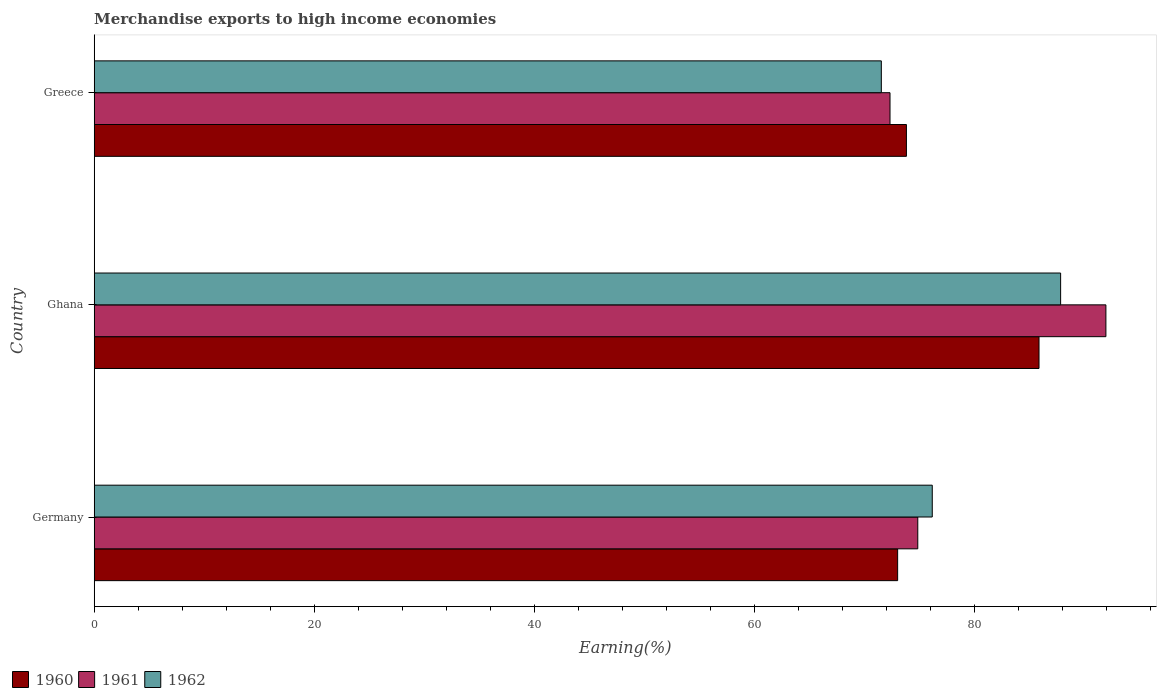How many different coloured bars are there?
Ensure brevity in your answer.  3. How many groups of bars are there?
Your answer should be compact. 3. Are the number of bars per tick equal to the number of legend labels?
Offer a terse response. Yes. Are the number of bars on each tick of the Y-axis equal?
Provide a succinct answer. Yes. How many bars are there on the 2nd tick from the top?
Provide a short and direct response. 3. In how many cases, is the number of bars for a given country not equal to the number of legend labels?
Give a very brief answer. 0. What is the percentage of amount earned from merchandise exports in 1960 in Germany?
Offer a very short reply. 73.01. Across all countries, what is the maximum percentage of amount earned from merchandise exports in 1960?
Offer a terse response. 85.85. Across all countries, what is the minimum percentage of amount earned from merchandise exports in 1960?
Keep it short and to the point. 73.01. In which country was the percentage of amount earned from merchandise exports in 1962 maximum?
Your answer should be compact. Ghana. What is the total percentage of amount earned from merchandise exports in 1962 in the graph?
Keep it short and to the point. 235.5. What is the difference between the percentage of amount earned from merchandise exports in 1962 in Germany and that in Greece?
Your answer should be very brief. 4.63. What is the difference between the percentage of amount earned from merchandise exports in 1962 in Greece and the percentage of amount earned from merchandise exports in 1960 in Ghana?
Keep it short and to the point. -14.33. What is the average percentage of amount earned from merchandise exports in 1960 per country?
Give a very brief answer. 77.56. What is the difference between the percentage of amount earned from merchandise exports in 1962 and percentage of amount earned from merchandise exports in 1960 in Greece?
Provide a short and direct response. -2.28. In how many countries, is the percentage of amount earned from merchandise exports in 1961 greater than 56 %?
Ensure brevity in your answer.  3. What is the ratio of the percentage of amount earned from merchandise exports in 1962 in Germany to that in Greece?
Your answer should be compact. 1.06. Is the difference between the percentage of amount earned from merchandise exports in 1962 in Ghana and Greece greater than the difference between the percentage of amount earned from merchandise exports in 1960 in Ghana and Greece?
Your response must be concise. Yes. What is the difference between the highest and the second highest percentage of amount earned from merchandise exports in 1961?
Your answer should be compact. 17.1. What is the difference between the highest and the lowest percentage of amount earned from merchandise exports in 1961?
Offer a terse response. 19.62. In how many countries, is the percentage of amount earned from merchandise exports in 1961 greater than the average percentage of amount earned from merchandise exports in 1961 taken over all countries?
Offer a terse response. 1. Is the sum of the percentage of amount earned from merchandise exports in 1961 in Germany and Greece greater than the maximum percentage of amount earned from merchandise exports in 1960 across all countries?
Keep it short and to the point. Yes. What does the 1st bar from the top in Ghana represents?
Offer a terse response. 1962. What does the 2nd bar from the bottom in Ghana represents?
Keep it short and to the point. 1961. Does the graph contain grids?
Your answer should be very brief. No. How many legend labels are there?
Keep it short and to the point. 3. What is the title of the graph?
Offer a terse response. Merchandise exports to high income economies. What is the label or title of the X-axis?
Offer a very short reply. Earning(%). What is the label or title of the Y-axis?
Your answer should be compact. Country. What is the Earning(%) of 1960 in Germany?
Your response must be concise. 73.01. What is the Earning(%) of 1961 in Germany?
Your response must be concise. 74.84. What is the Earning(%) in 1962 in Germany?
Give a very brief answer. 76.15. What is the Earning(%) of 1960 in Ghana?
Your response must be concise. 85.85. What is the Earning(%) of 1961 in Ghana?
Provide a succinct answer. 91.93. What is the Earning(%) in 1962 in Ghana?
Ensure brevity in your answer.  87.82. What is the Earning(%) in 1960 in Greece?
Give a very brief answer. 73.81. What is the Earning(%) of 1961 in Greece?
Provide a short and direct response. 72.31. What is the Earning(%) of 1962 in Greece?
Provide a succinct answer. 71.53. Across all countries, what is the maximum Earning(%) in 1960?
Make the answer very short. 85.85. Across all countries, what is the maximum Earning(%) of 1961?
Keep it short and to the point. 91.93. Across all countries, what is the maximum Earning(%) of 1962?
Make the answer very short. 87.82. Across all countries, what is the minimum Earning(%) of 1960?
Give a very brief answer. 73.01. Across all countries, what is the minimum Earning(%) in 1961?
Offer a very short reply. 72.31. Across all countries, what is the minimum Earning(%) of 1962?
Give a very brief answer. 71.53. What is the total Earning(%) in 1960 in the graph?
Your answer should be very brief. 232.67. What is the total Earning(%) in 1961 in the graph?
Provide a succinct answer. 239.09. What is the total Earning(%) of 1962 in the graph?
Provide a short and direct response. 235.5. What is the difference between the Earning(%) in 1960 in Germany and that in Ghana?
Provide a succinct answer. -12.85. What is the difference between the Earning(%) of 1961 in Germany and that in Ghana?
Your answer should be very brief. -17.09. What is the difference between the Earning(%) of 1962 in Germany and that in Ghana?
Ensure brevity in your answer.  -11.66. What is the difference between the Earning(%) of 1960 in Germany and that in Greece?
Make the answer very short. -0.8. What is the difference between the Earning(%) in 1961 in Germany and that in Greece?
Offer a very short reply. 2.52. What is the difference between the Earning(%) in 1962 in Germany and that in Greece?
Your answer should be very brief. 4.63. What is the difference between the Earning(%) of 1960 in Ghana and that in Greece?
Your answer should be very brief. 12.05. What is the difference between the Earning(%) of 1961 in Ghana and that in Greece?
Give a very brief answer. 19.62. What is the difference between the Earning(%) of 1962 in Ghana and that in Greece?
Your answer should be very brief. 16.29. What is the difference between the Earning(%) of 1960 in Germany and the Earning(%) of 1961 in Ghana?
Offer a very short reply. -18.93. What is the difference between the Earning(%) of 1960 in Germany and the Earning(%) of 1962 in Ghana?
Make the answer very short. -14.81. What is the difference between the Earning(%) in 1961 in Germany and the Earning(%) in 1962 in Ghana?
Ensure brevity in your answer.  -12.98. What is the difference between the Earning(%) of 1960 in Germany and the Earning(%) of 1961 in Greece?
Make the answer very short. 0.69. What is the difference between the Earning(%) of 1960 in Germany and the Earning(%) of 1962 in Greece?
Offer a very short reply. 1.48. What is the difference between the Earning(%) of 1961 in Germany and the Earning(%) of 1962 in Greece?
Ensure brevity in your answer.  3.31. What is the difference between the Earning(%) in 1960 in Ghana and the Earning(%) in 1961 in Greece?
Offer a very short reply. 13.54. What is the difference between the Earning(%) of 1960 in Ghana and the Earning(%) of 1962 in Greece?
Offer a very short reply. 14.33. What is the difference between the Earning(%) of 1961 in Ghana and the Earning(%) of 1962 in Greece?
Your response must be concise. 20.41. What is the average Earning(%) in 1960 per country?
Give a very brief answer. 77.56. What is the average Earning(%) of 1961 per country?
Keep it short and to the point. 79.7. What is the average Earning(%) in 1962 per country?
Give a very brief answer. 78.5. What is the difference between the Earning(%) of 1960 and Earning(%) of 1961 in Germany?
Provide a succinct answer. -1.83. What is the difference between the Earning(%) in 1960 and Earning(%) in 1962 in Germany?
Offer a terse response. -3.15. What is the difference between the Earning(%) in 1961 and Earning(%) in 1962 in Germany?
Your response must be concise. -1.32. What is the difference between the Earning(%) in 1960 and Earning(%) in 1961 in Ghana?
Provide a succinct answer. -6.08. What is the difference between the Earning(%) in 1960 and Earning(%) in 1962 in Ghana?
Keep it short and to the point. -1.96. What is the difference between the Earning(%) of 1961 and Earning(%) of 1962 in Ghana?
Offer a terse response. 4.12. What is the difference between the Earning(%) of 1960 and Earning(%) of 1961 in Greece?
Your answer should be very brief. 1.49. What is the difference between the Earning(%) in 1960 and Earning(%) in 1962 in Greece?
Your answer should be very brief. 2.28. What is the difference between the Earning(%) in 1961 and Earning(%) in 1962 in Greece?
Your answer should be compact. 0.79. What is the ratio of the Earning(%) in 1960 in Germany to that in Ghana?
Offer a terse response. 0.85. What is the ratio of the Earning(%) of 1961 in Germany to that in Ghana?
Your answer should be very brief. 0.81. What is the ratio of the Earning(%) of 1962 in Germany to that in Ghana?
Offer a terse response. 0.87. What is the ratio of the Earning(%) of 1960 in Germany to that in Greece?
Keep it short and to the point. 0.99. What is the ratio of the Earning(%) in 1961 in Germany to that in Greece?
Keep it short and to the point. 1.03. What is the ratio of the Earning(%) of 1962 in Germany to that in Greece?
Your answer should be very brief. 1.06. What is the ratio of the Earning(%) of 1960 in Ghana to that in Greece?
Give a very brief answer. 1.16. What is the ratio of the Earning(%) in 1961 in Ghana to that in Greece?
Provide a succinct answer. 1.27. What is the ratio of the Earning(%) of 1962 in Ghana to that in Greece?
Offer a very short reply. 1.23. What is the difference between the highest and the second highest Earning(%) of 1960?
Keep it short and to the point. 12.05. What is the difference between the highest and the second highest Earning(%) in 1961?
Offer a terse response. 17.09. What is the difference between the highest and the second highest Earning(%) in 1962?
Keep it short and to the point. 11.66. What is the difference between the highest and the lowest Earning(%) of 1960?
Give a very brief answer. 12.85. What is the difference between the highest and the lowest Earning(%) in 1961?
Provide a short and direct response. 19.62. What is the difference between the highest and the lowest Earning(%) in 1962?
Your answer should be very brief. 16.29. 